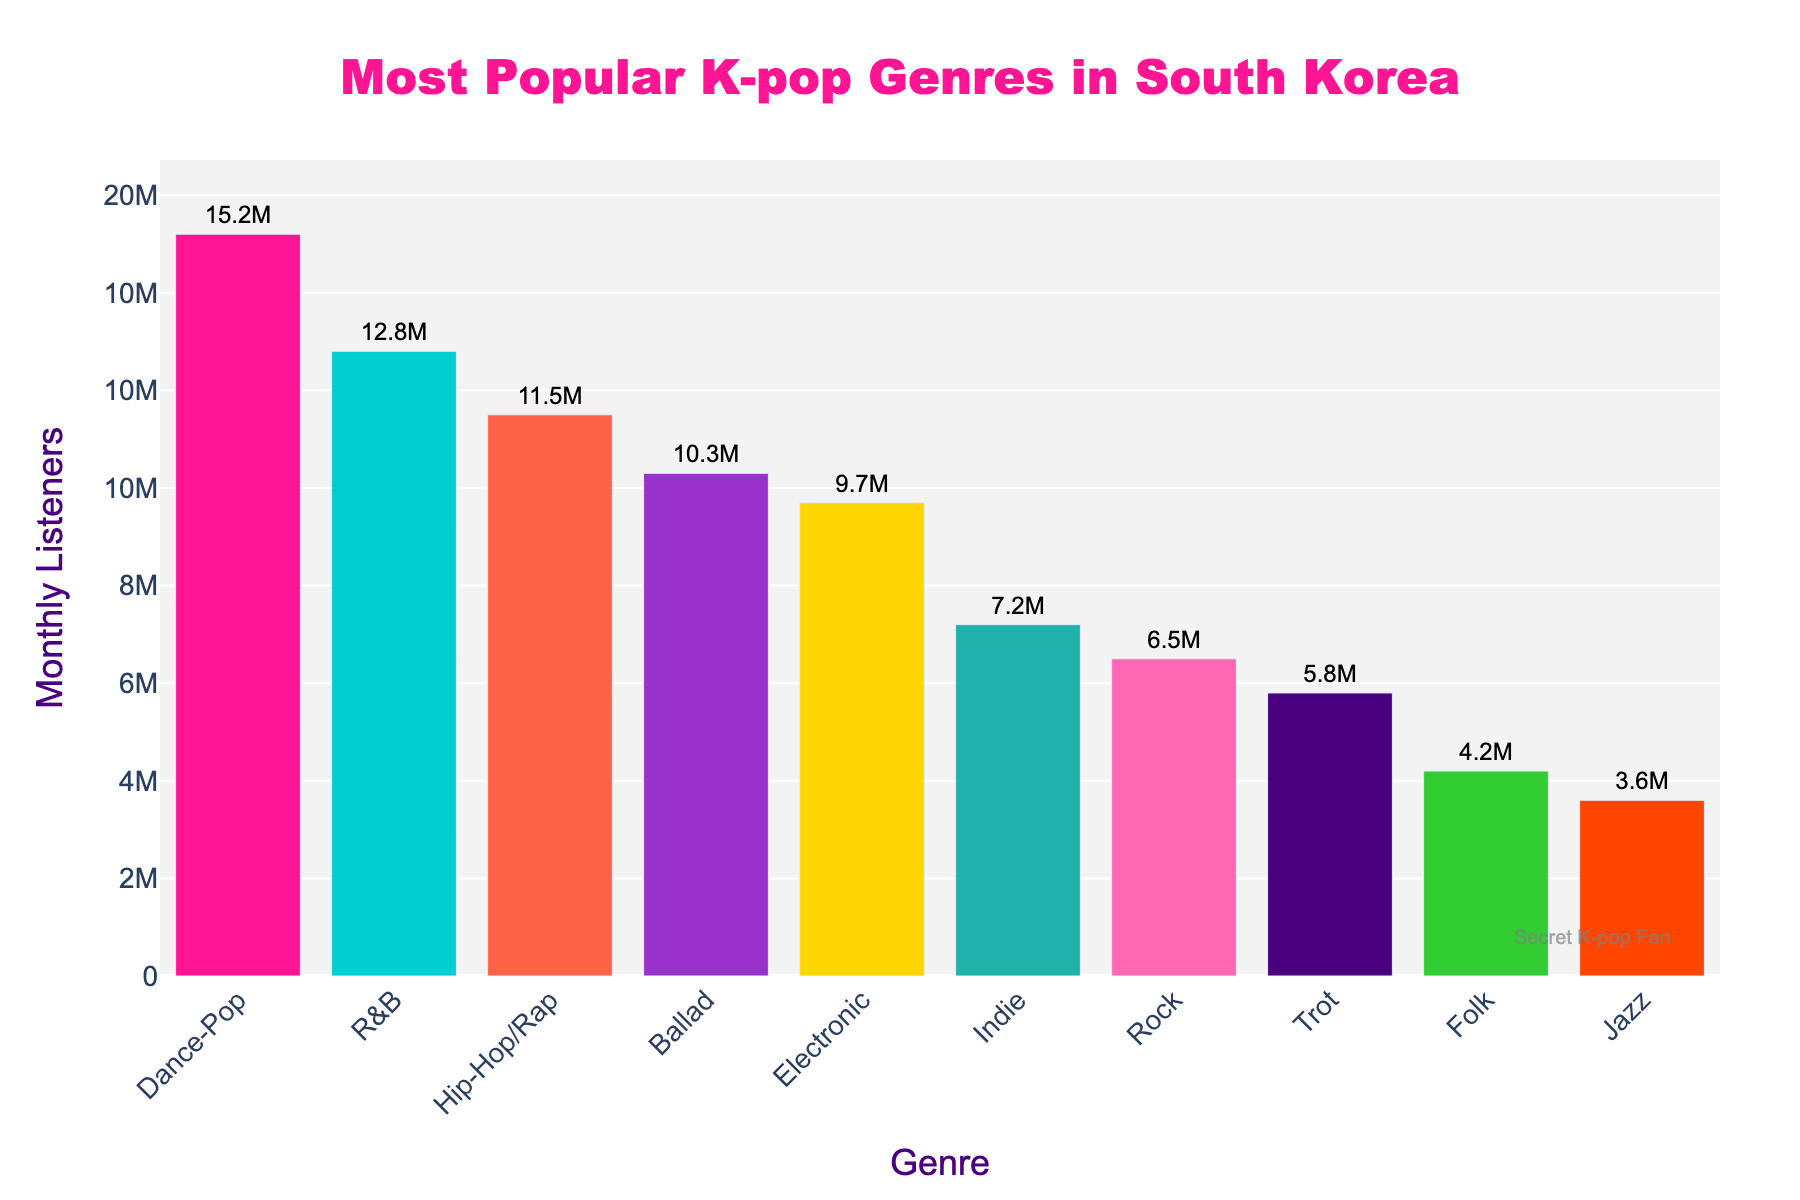Which genre has the most monthly listeners? The genre with the highest bar represents the genre with the most listeners. According to the chart, Dance-Pop has the highest bar with 15.2M monthly listeners.
Answer: Dance-Pop Which genre has more monthly listeners, Hip-Hop/Rap or Ballad? By comparing the heights of the bars, Hip-Hop/Rap has more listeners (11.5M) than Ballad (10.3M).
Answer: Hip-Hop/Rap What is the total number of monthly listeners for Jazz and Folk combined? By adding the monthly listeners for Jazz (3.6M) and Folk (4.2M), the total is 3.6M + 4.2M = 7.8M.
Answer: 7.8M What is the approximate difference in monthly listeners between the most and least popular genres? The genre with the most listeners is Dance-Pop (15.2M) and the least popular is Jazz (3.6M). The difference is 15.2M - 3.6M = 11.6M.
Answer: 11.6M Which color represents the genre R&B on the bar chart? The bar for R&B is shown in the second position and is colored with a very distinct color. From the color palette provided, the second color is a light blue-turquoise hue.
Answer: Light Blue-Turquoise What is the overall trend in monthly listeners as you move from Dance-Pop to Jazz? Observing the heights of the bars from left to right, there is a general decreasing trend in monthly listeners from Dance-Pop towards Jazz.
Answer: Decreasing trend How many genres have more than 10 million monthly listeners? By examining the bars, Dance-Pop, R&B, and Hip-Hop/Rap have more than 10 million listeners. This results in three genres.
Answer: 3 What's the average number of monthly listeners for the genres that have more than 10 million listeners? The genres with over 10 million listeners are Dance-Pop (15.2M), R&B (12.8M), and Hip-Hop/Rap (11.5M). The average is calculated as (15.2M + 12.8M + 11.5M) / 3 = 13.17M.
Answer: 13.17M Which genres have fewer monthly listeners than Indie music? Comparing the monthly listeners, Indie has 7.2M listeners. The genres with fewer listeners are Rock (6.5M), Trot (5.8M), Folk (4.2M), and Jazz (3.6M).
Answer: Rock, Trot, Folk, Jazz What is the median number of monthly listeners? Sorting the monthly listeners data in ascending order [3.6M, 4.2M, 5.8M, 6.5M, 7.2M, 9.7M, 10.3M, 11.5M, 12.8M, 15.2M], the median value is the average of the 5th (7.2M) and 6th (9.7M) values: (7.2M + 9.7M) / 2 = 8.45M.
Answer: 8.45M 